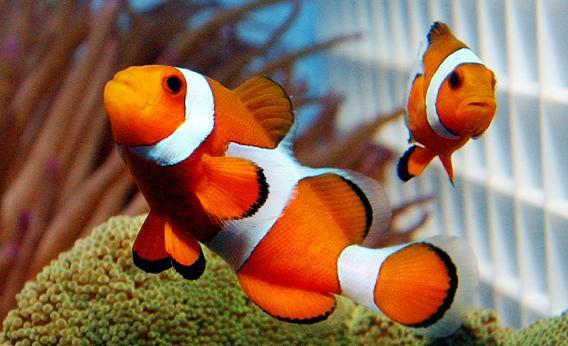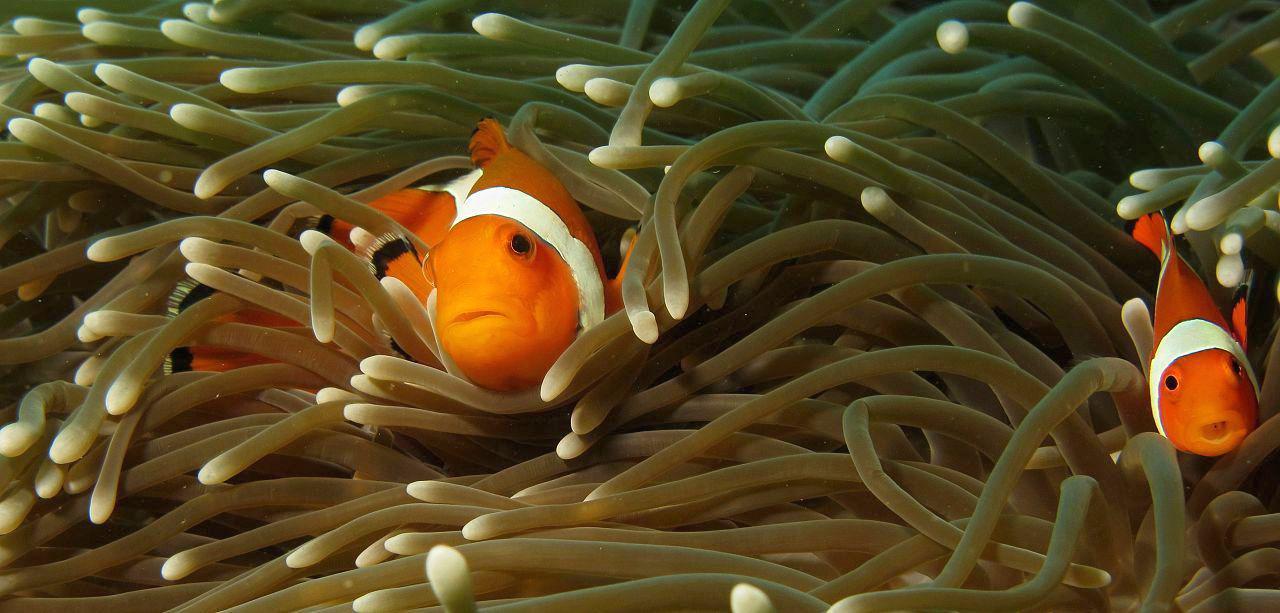The first image is the image on the left, the second image is the image on the right. Considering the images on both sides, is "There are 4 clownfish." valid? Answer yes or no. Yes. 